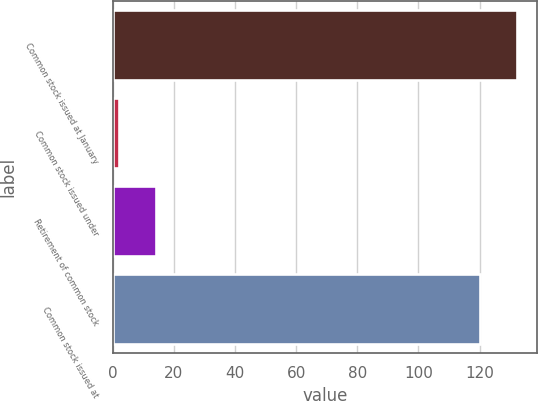<chart> <loc_0><loc_0><loc_500><loc_500><bar_chart><fcel>Common stock issued at January<fcel>Common stock issued under<fcel>Retirement of common stock<fcel>Common stock issued at<nl><fcel>132.26<fcel>1.9<fcel>14.16<fcel>120<nl></chart> 